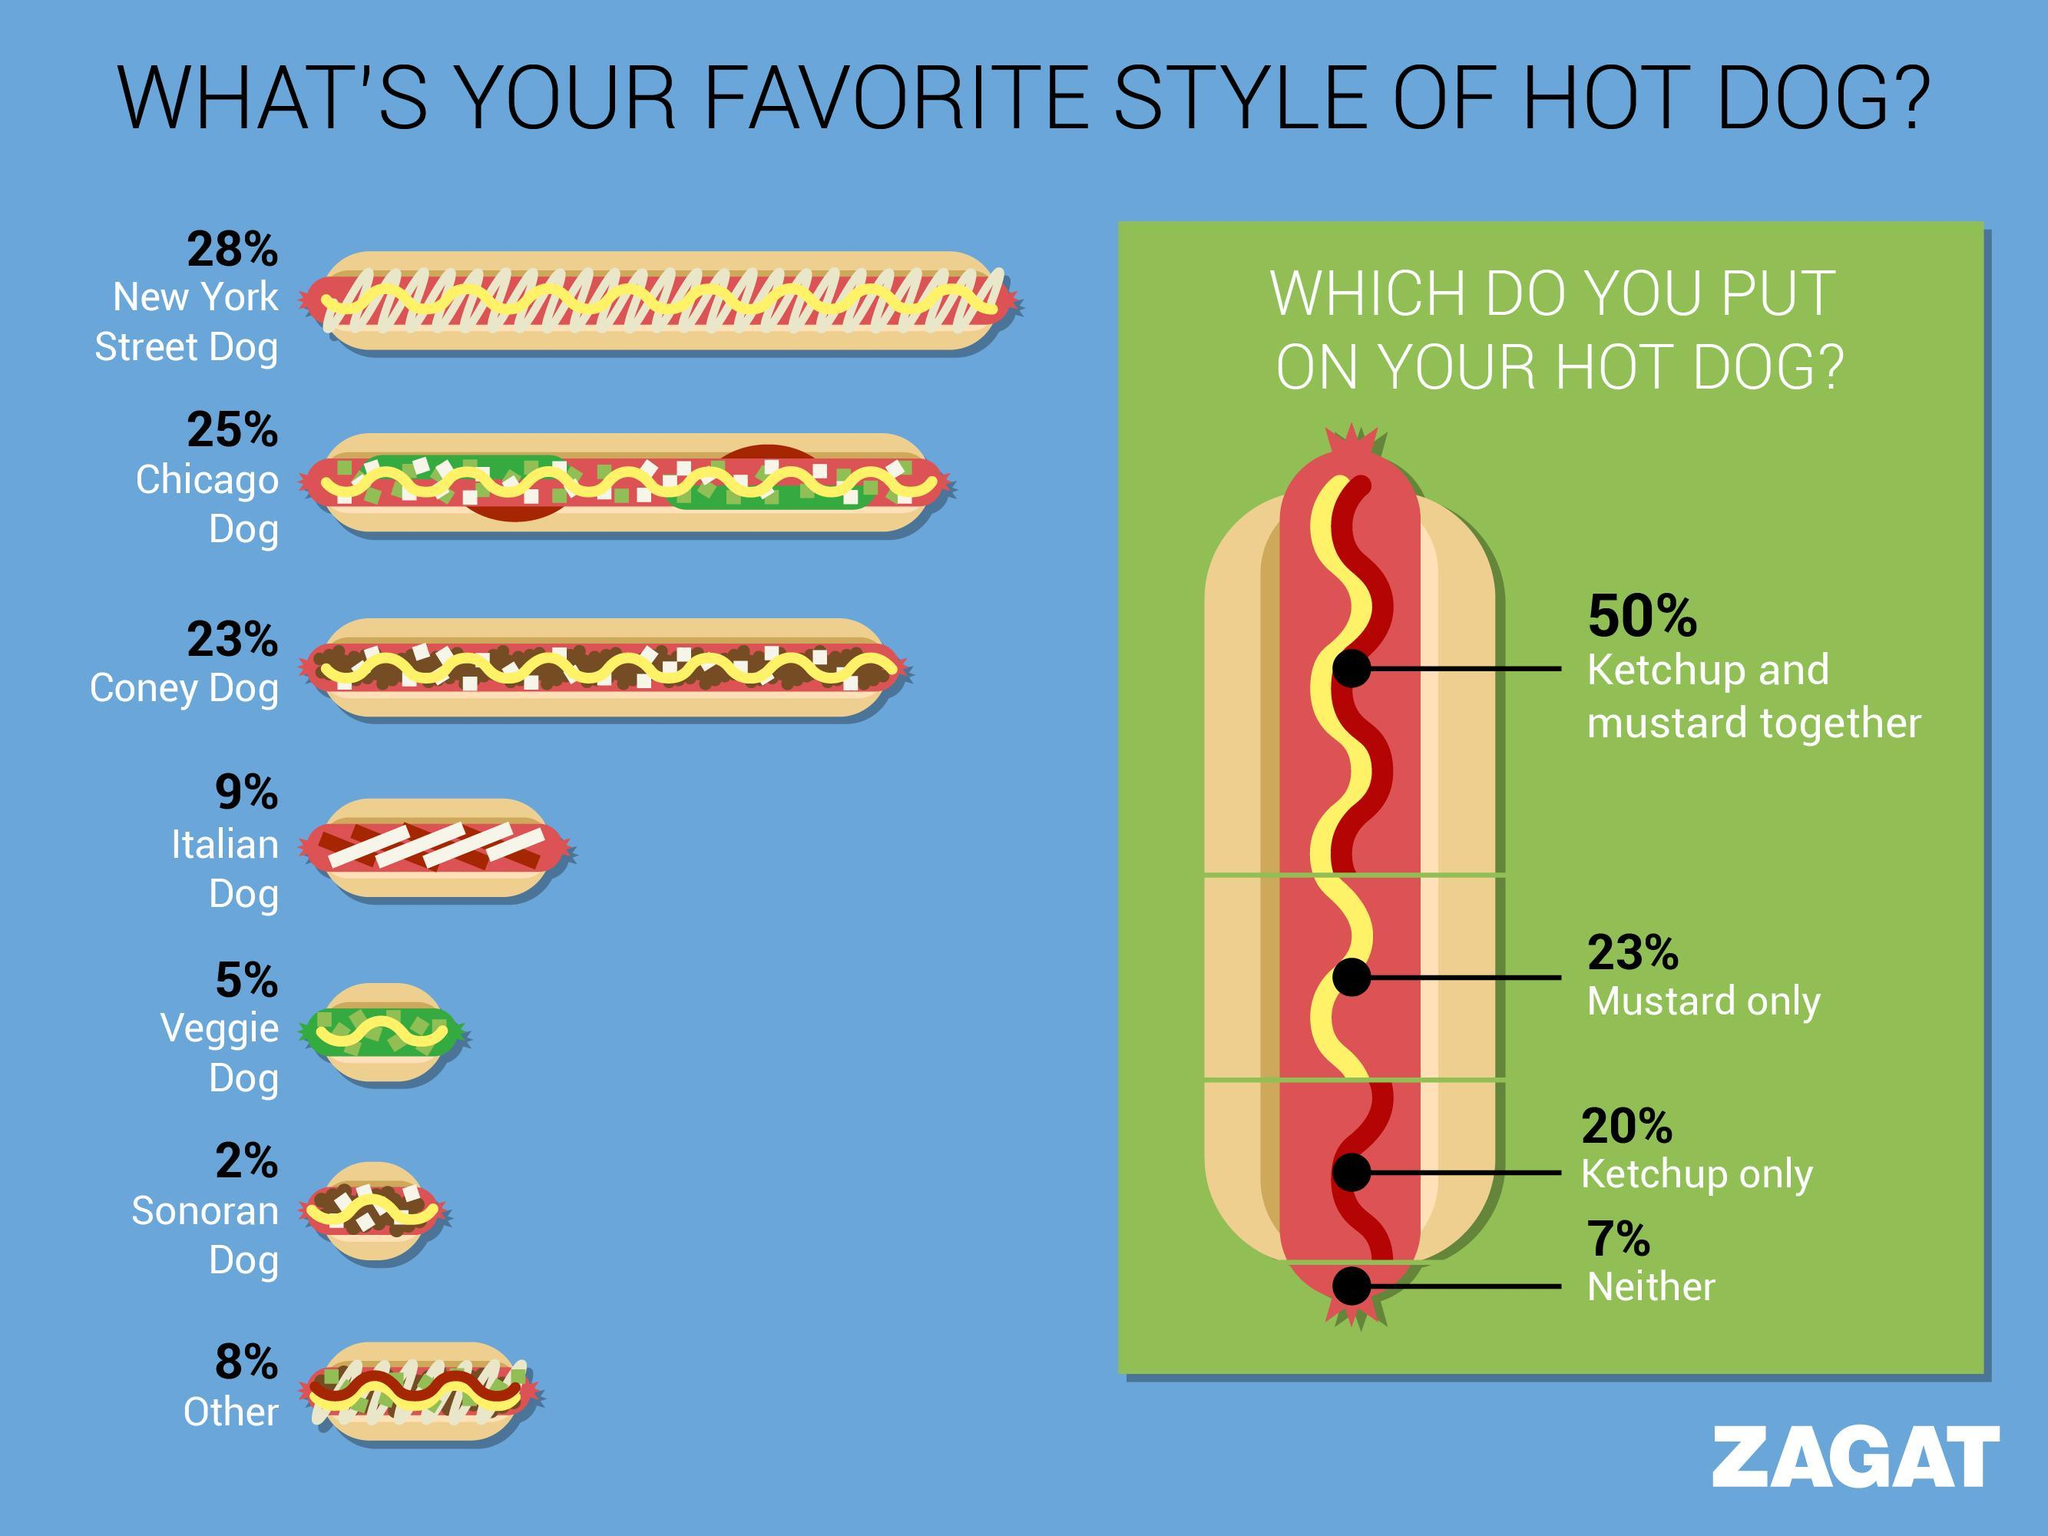What percent of people do not want any dressing?
Answer the question with a short phrase. 7% Which dressing is most preferred by people- Ketchup and mustard together, mustard only or ketchup only? Ketchup and mustard together What percent of people like both Chicago dog and Coney dog? 48% How many dressings or sauces are shown? 2 